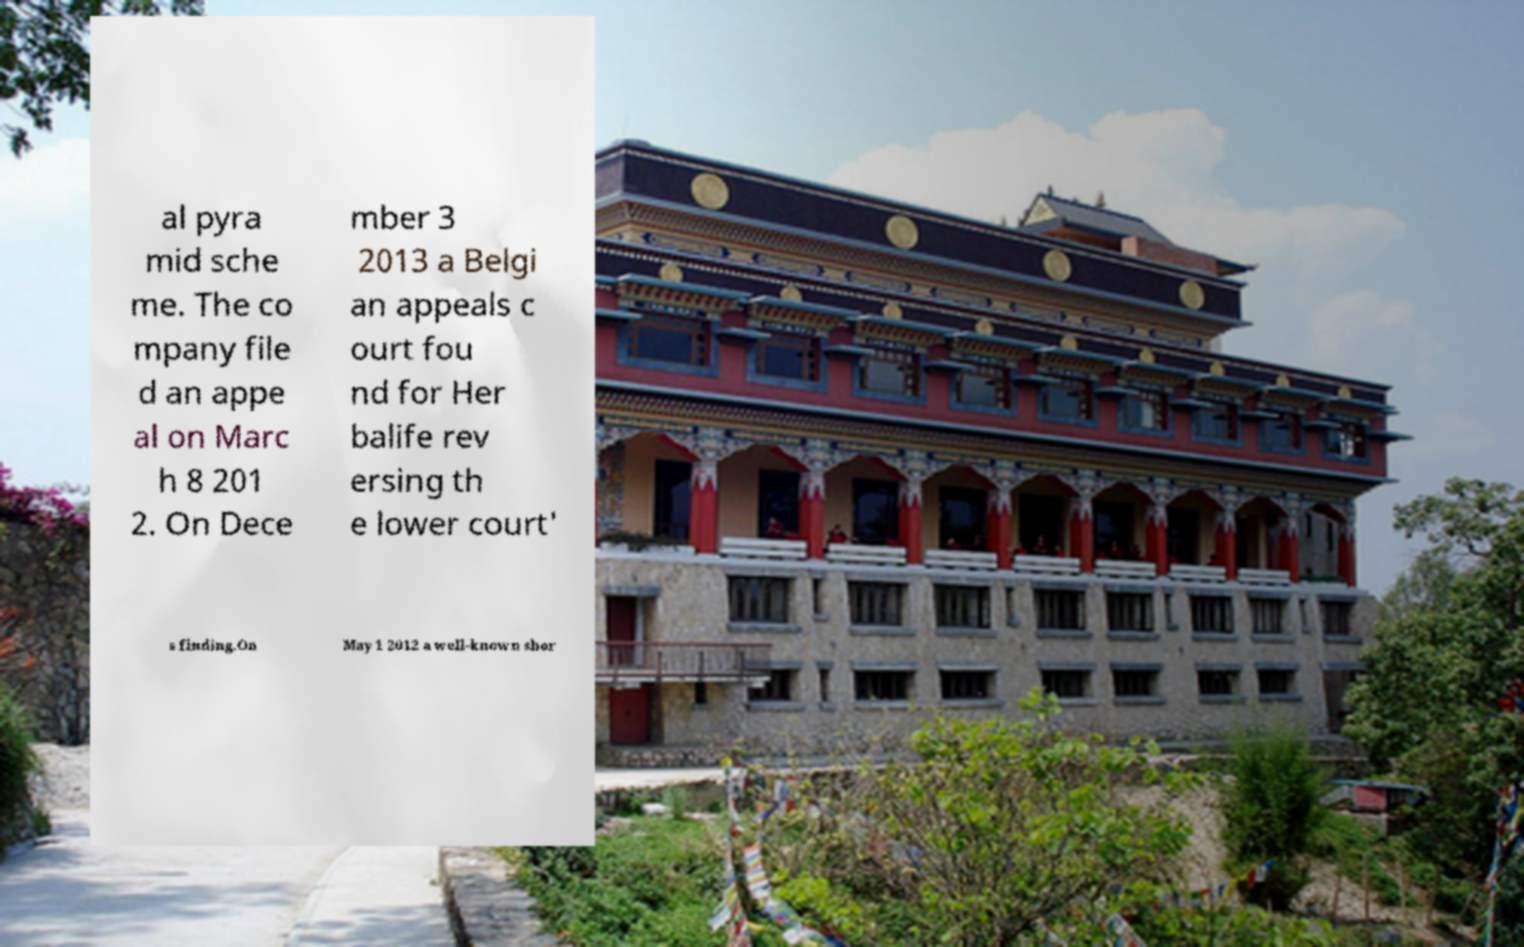There's text embedded in this image that I need extracted. Can you transcribe it verbatim? al pyra mid sche me. The co mpany file d an appe al on Marc h 8 201 2. On Dece mber 3 2013 a Belgi an appeals c ourt fou nd for Her balife rev ersing th e lower court' s finding.On May 1 2012 a well-known shor 